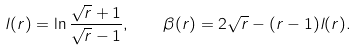Convert formula to latex. <formula><loc_0><loc_0><loc_500><loc_500>l ( r ) = \ln \frac { \sqrt { r } + 1 } { \sqrt { r } - 1 } , \quad \beta ( r ) = 2 \sqrt { r } - ( r - 1 ) l ( r ) .</formula> 